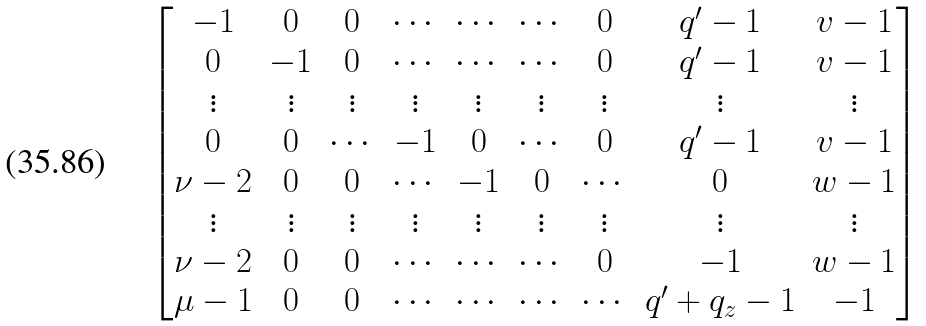Convert formula to latex. <formula><loc_0><loc_0><loc_500><loc_500>\begin{bmatrix} - 1 & 0 & 0 & \cdots & \cdots & \cdots & 0 & q ^ { \prime } - 1 & v - 1 \\ 0 & - 1 & 0 & \cdots & \cdots & \cdots & 0 & q ^ { \prime } - 1 & v - 1 \\ \vdots & \vdots & \vdots & \vdots & \vdots & \vdots & \vdots & \vdots & \vdots \\ 0 & 0 & \cdots & - 1 & 0 & \cdots & 0 & q ^ { \prime } - 1 & v - 1 \\ \nu - 2 & 0 & 0 & \cdots & - 1 & 0 & \cdots & 0 & w - 1 \\ \vdots & \vdots & \vdots & \vdots & \vdots & \vdots & \vdots & \vdots & \vdots \\ \nu - 2 & 0 & 0 & \cdots & \cdots & \cdots & 0 & - 1 & w - 1 \\ \mu - 1 & 0 & 0 & \cdots & \cdots & \cdots & \cdots & q ^ { \prime } + q _ { z } - 1 & - 1 \\ \end{bmatrix}</formula> 